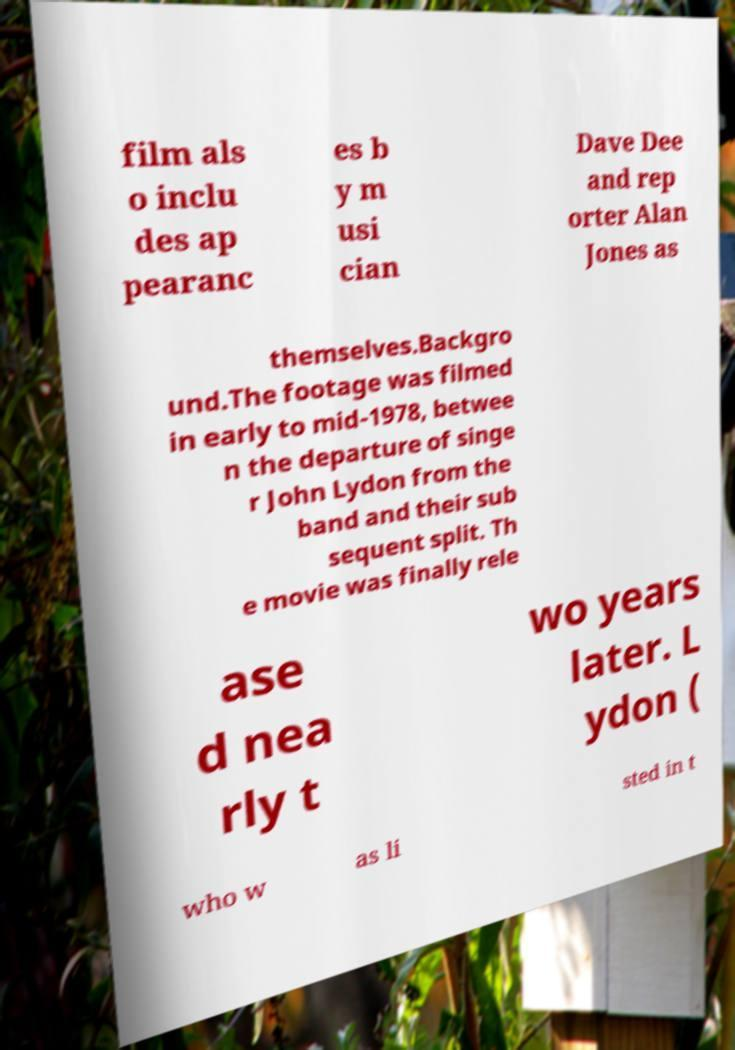What messages or text are displayed in this image? I need them in a readable, typed format. film als o inclu des ap pearanc es b y m usi cian Dave Dee and rep orter Alan Jones as themselves.Backgro und.The footage was filmed in early to mid-1978, betwee n the departure of singe r John Lydon from the band and their sub sequent split. Th e movie was finally rele ase d nea rly t wo years later. L ydon ( who w as li sted in t 